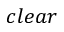Convert formula to latex. <formula><loc_0><loc_0><loc_500><loc_500>c l e a r</formula> 